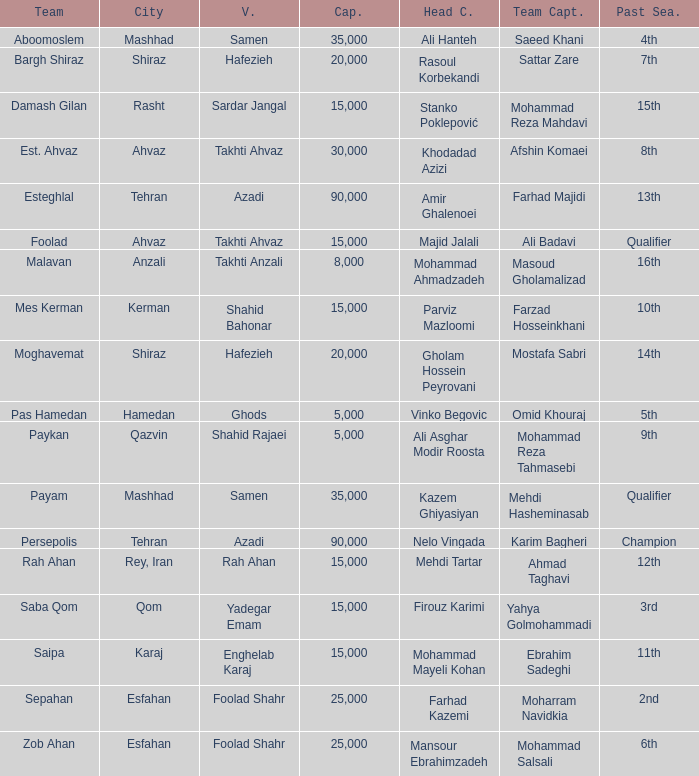What is the Capacity of the Venue of Head Coach Ali Asghar Modir Roosta? 5000.0. 